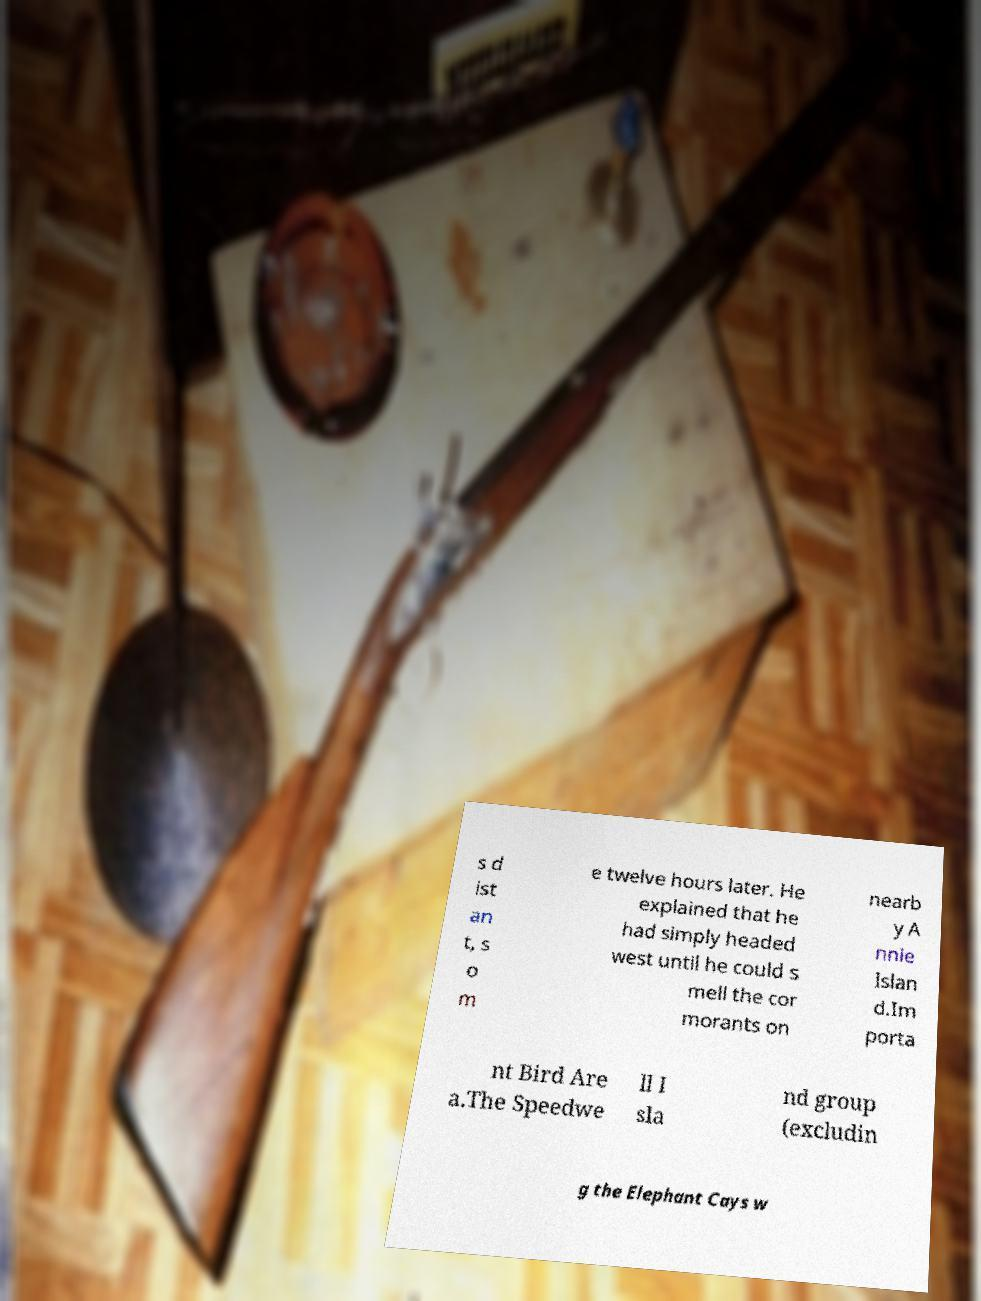What messages or text are displayed in this image? I need them in a readable, typed format. s d ist an t, s o m e twelve hours later. He explained that he had simply headed west until he could s mell the cor morants on nearb y A nnie Islan d.Im porta nt Bird Are a.The Speedwe ll I sla nd group (excludin g the Elephant Cays w 